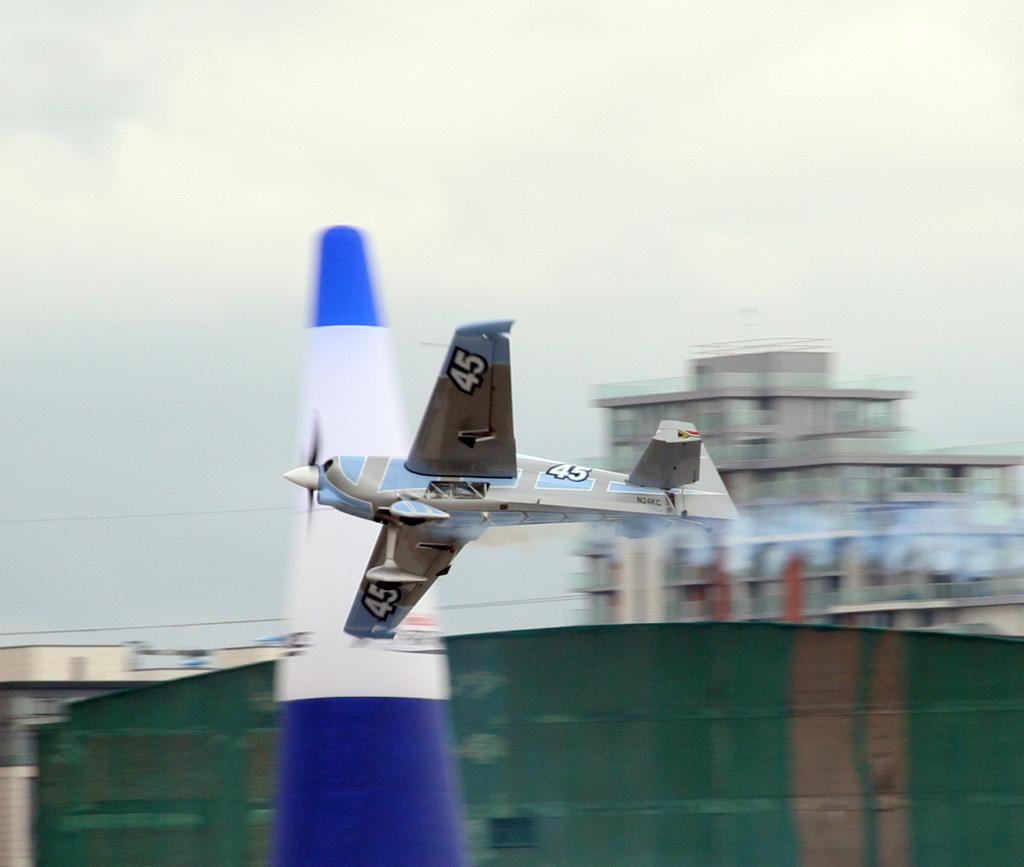<image>
Describe the image concisely. A prop plane with number 45 flies low to the ground past a blue white cone. 